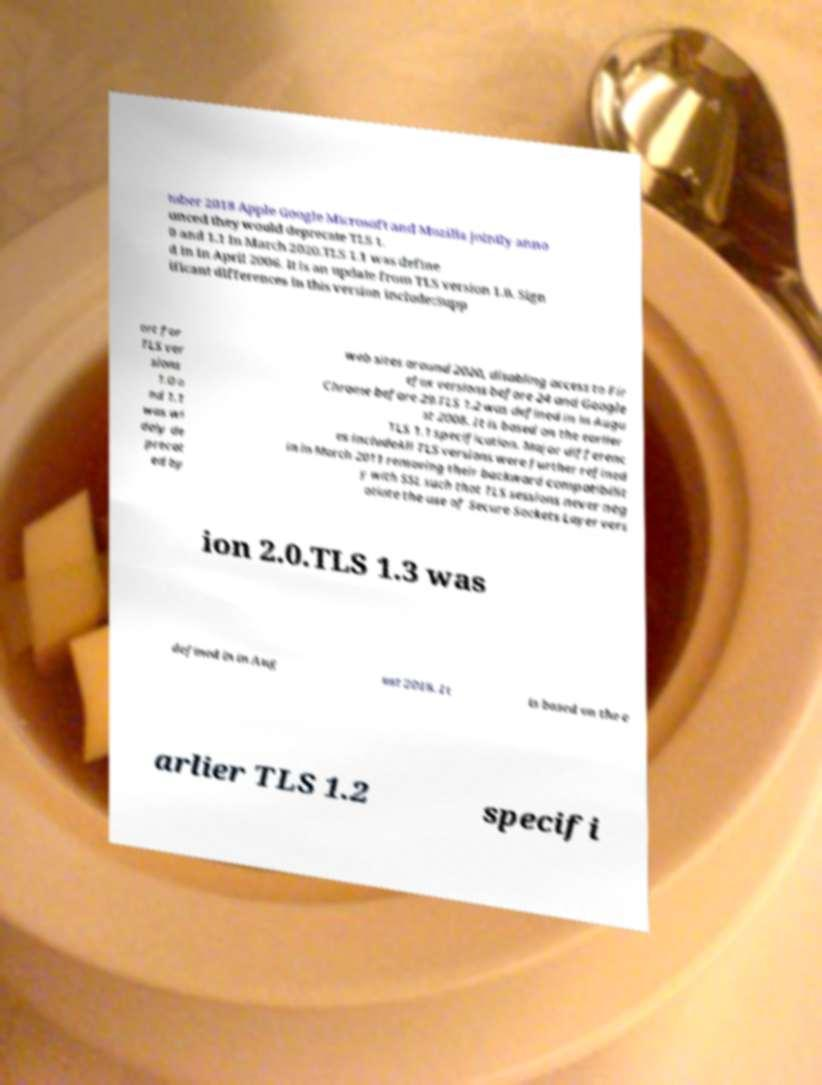Could you assist in decoding the text presented in this image and type it out clearly? tober 2018 Apple Google Microsoft and Mozilla jointly anno unced they would deprecate TLS 1. 0 and 1.1 in March 2020.TLS 1.1 was define d in in April 2006. It is an update from TLS version 1.0. Sign ificant differences in this version include:Supp ort for TLS ver sions 1.0 a nd 1.1 was wi dely de precat ed by web sites around 2020, disabling access to Fir efox versions before 24 and Google Chrome before 29.TLS 1.2 was defined in in Augu st 2008. It is based on the earlier TLS 1.1 specification. Major differenc es includeAll TLS versions were further refined in in March 2011 removing their backward compatibilit y with SSL such that TLS sessions never neg otiate the use of Secure Sockets Layer vers ion 2.0.TLS 1.3 was defined in in Aug ust 2018. It is based on the e arlier TLS 1.2 specifi 